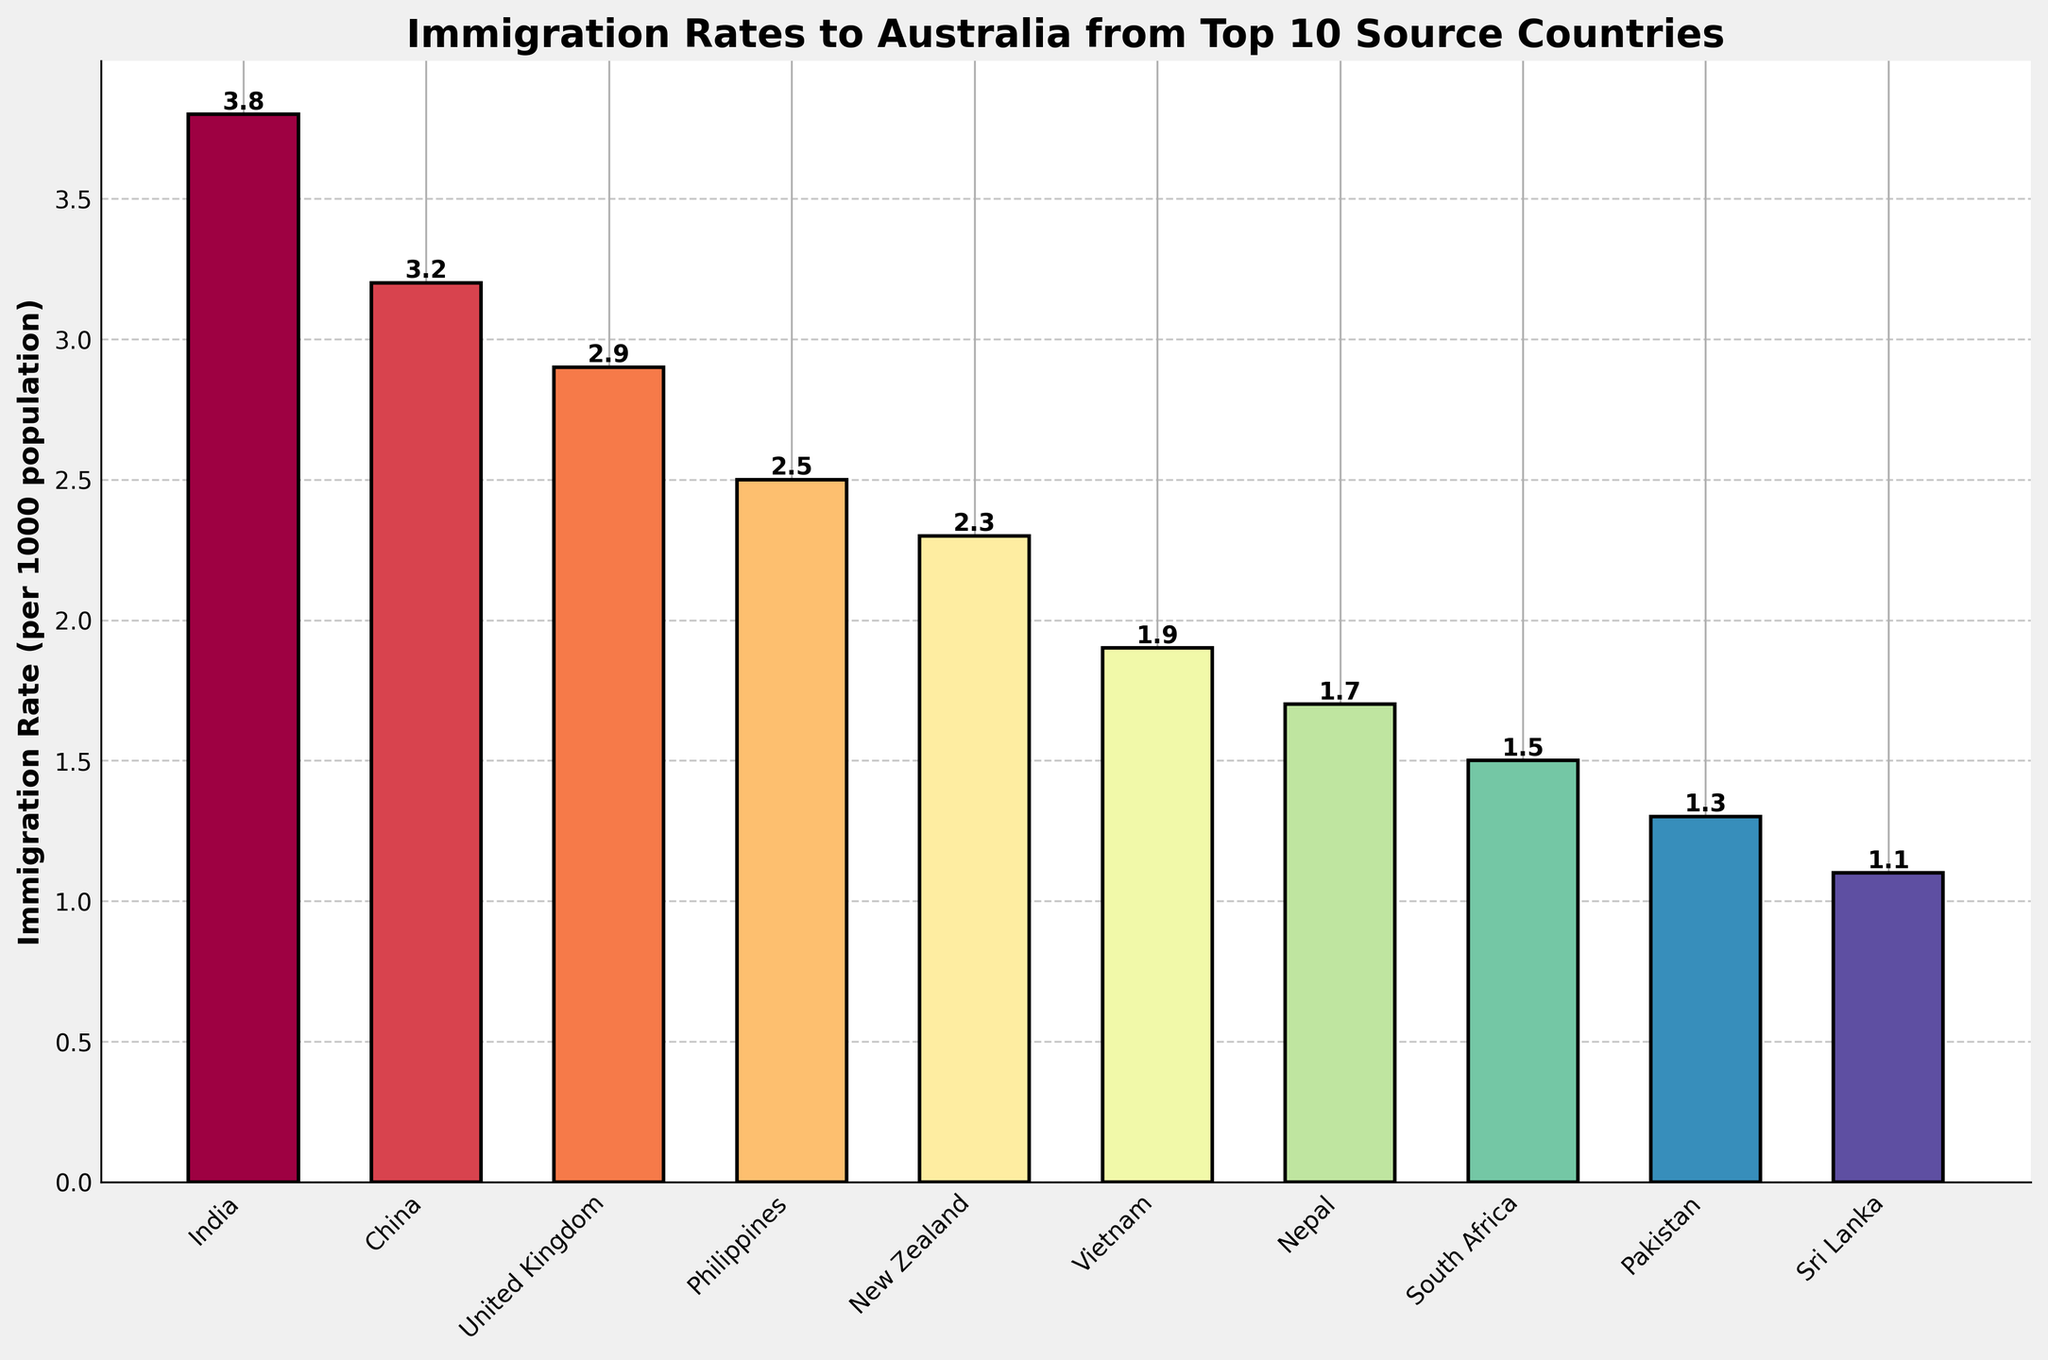What is the highest immigration rate to Australia from any country in the past decade? Look at the bar representing the country with the highest bar height. India has the highest bar with an immigration rate of 3.8.
Answer: 3.8 Which country has the lowest immigration rate to Australia among the top 10 source countries? Identify the country with the smallest bar. Sri Lanka has the lowest bar height, suggesting an immigration rate of 1.1.
Answer: Sri Lanka How many countries have an immigration rate of 2.5 or higher? Visually count the bars that reach or exceed the 2.5 mark on the y-axis. The countries are India, China, the United Kingdom, and the Philippines, making it 4 countries in total.
Answer: 4 What is the combined immigration rate of China and New Zealand? Find the heights of the bars for China and New Zealand and add them together. China's rate is 3.2 and New Zealand's is 2.3, so the combined rate is 3.2 + 2.3 = 5.5.
Answer: 5.5 Rank the countries in ascending order of their immigration rates. Arrange the countries from the smallest bar height to the largest. The order is Sri Lanka, Pakistan, South Africa, Nepal, Vietnam, New Zealand, Philippines, United Kingdom, China, and India.
Answer: Sri Lanka, Pakistan, South Africa, Nepal, Vietnam, New Zealand, Philippines, United Kingdom, China, India Which country has an immigration rate just below 2.0? Identify the country with a bar height slightly under the 2.0 mark. Vietnam has an immigration rate of 1.9.
Answer: Vietnam How many countries have a higher immigration rate than the Philippines? Count the bars taller than the bar representing the Philippines. The countries (India, China, and the United Kingdom) total 3.
Answer: 3 What is the average immigration rate among these top 10 source countries? Add up the immigration rates for all 10 countries and divide by 10. The sum is 3.8 + 3.2 + 2.9 + 2.5 + 2.3 + 1.9 + 1.7 + 1.5 + 1.3 + 1.1 = 22.2, hence the average is 22.2 / 10 = 2.22.
Answer: 2.22 Is the immigration rate of Nepal greater than that of Vietnam? Compare the height of the bars for Nepal and Vietnam. Nepal's bar is shorter with a rate of 1.7, while Vietnam's rate is 1.9.
Answer: No 